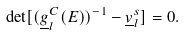Convert formula to latex. <formula><loc_0><loc_0><loc_500><loc_500>\det [ ( \underline { g } _ { l } ^ { C } ( E ) ) ^ { - 1 } - \underline { v } ^ { s } _ { l } ] = 0 .</formula> 